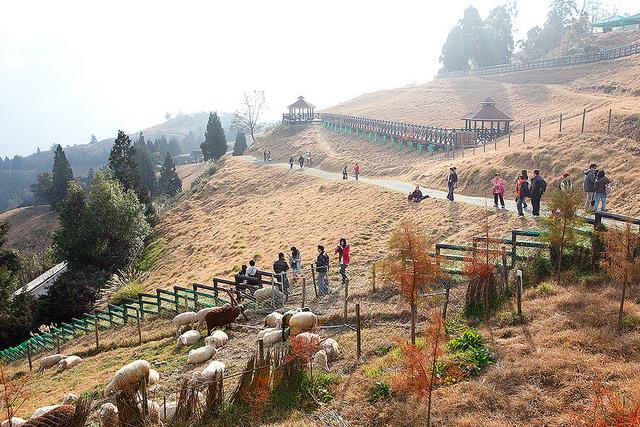What are the two domed structures?
Quick response, please. Gazebos. How many gazebos do you see?
Be succinct. 2. Is this a track set up for high hurdle competition?
Answer briefly. No. 